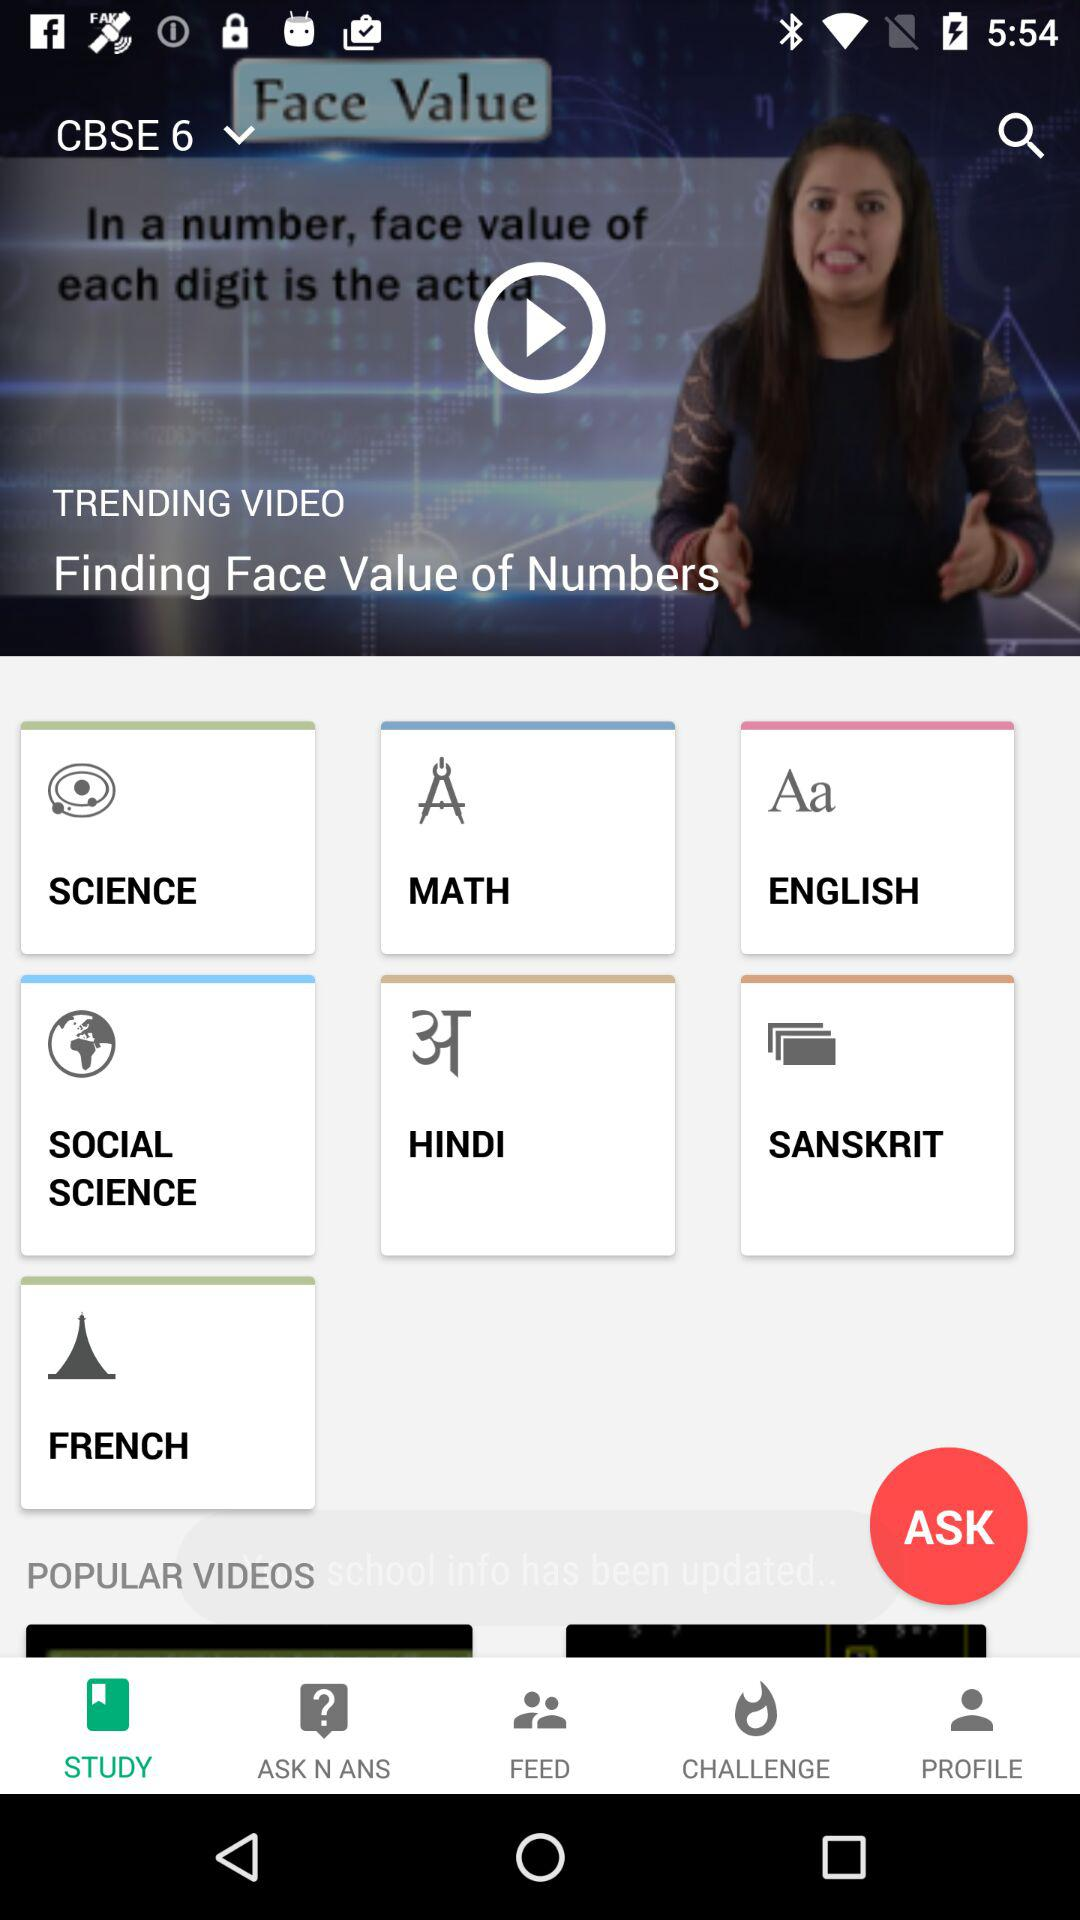Which option is selected? The selected options are "CBSE 6" and "STUDY". 